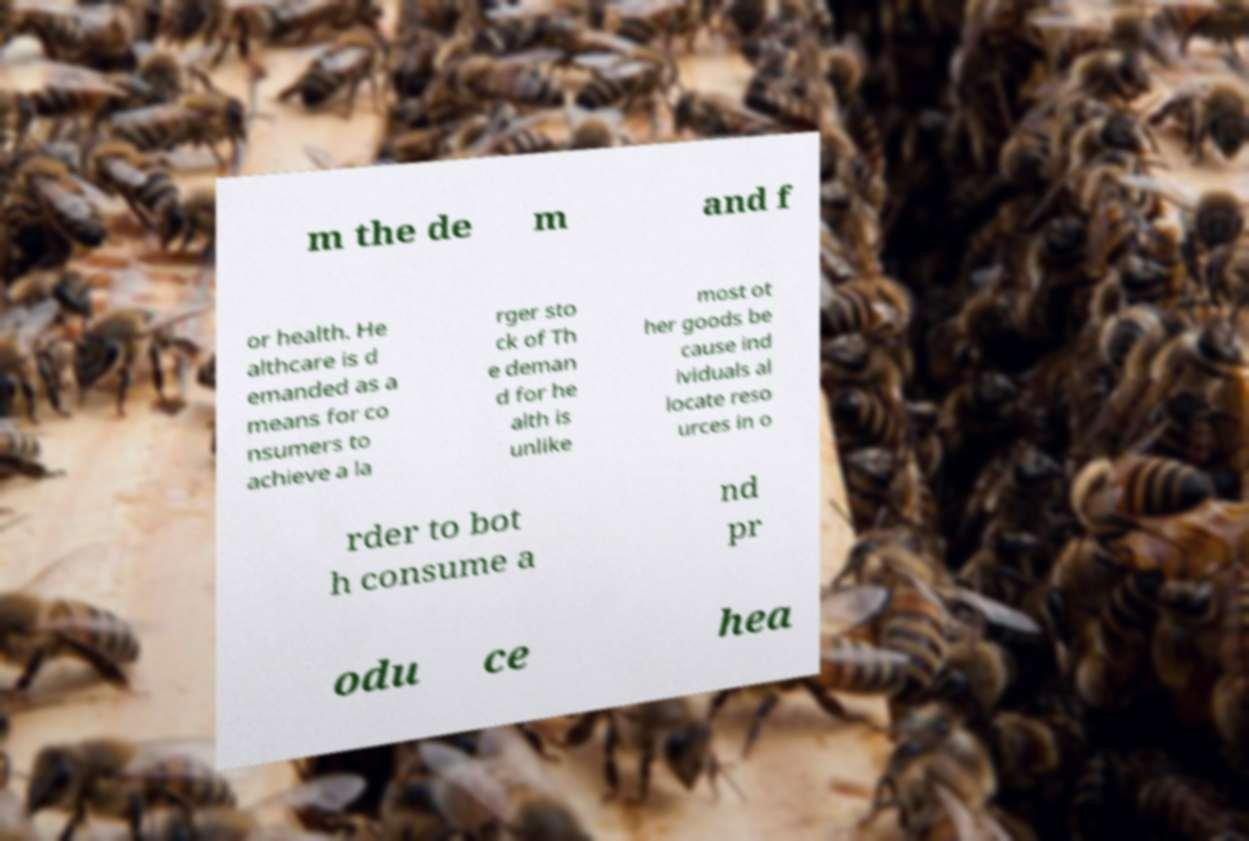What messages or text are displayed in this image? I need them in a readable, typed format. m the de m and f or health. He althcare is d emanded as a means for co nsumers to achieve a la rger sto ck of Th e deman d for he alth is unlike most ot her goods be cause ind ividuals al locate reso urces in o rder to bot h consume a nd pr odu ce hea 